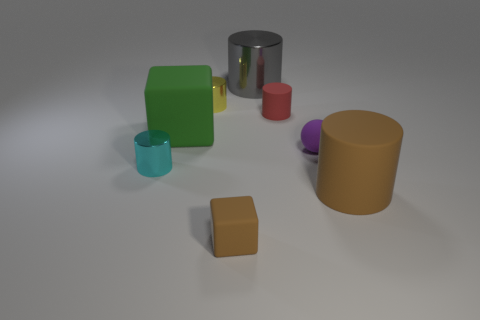Subtract all small cyan metal cylinders. How many cylinders are left? 4 Subtract all red cylinders. How many cylinders are left? 4 Subtract all green cylinders. Subtract all red spheres. How many cylinders are left? 5 Add 1 big metal cylinders. How many objects exist? 9 Subtract all blocks. How many objects are left? 6 Add 6 large blue rubber objects. How many large blue rubber objects exist? 6 Subtract 0 green spheres. How many objects are left? 8 Subtract all tiny gray blocks. Subtract all small yellow cylinders. How many objects are left? 7 Add 8 brown blocks. How many brown blocks are left? 9 